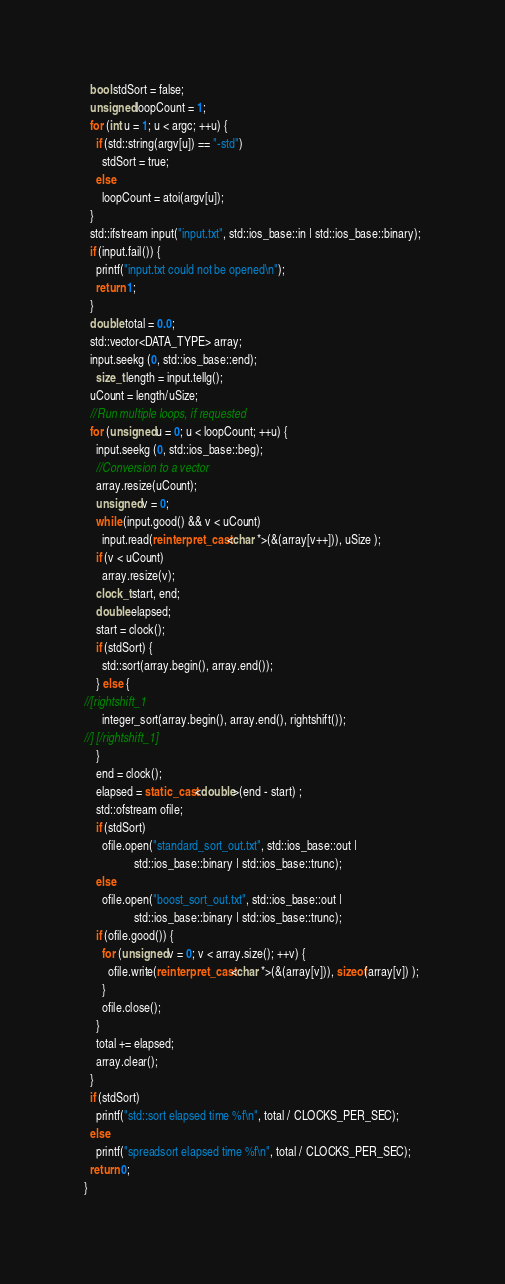<code> <loc_0><loc_0><loc_500><loc_500><_C++_>  bool stdSort = false;
  unsigned loopCount = 1;
  for (int u = 1; u < argc; ++u) {
    if (std::string(argv[u]) == "-std")
      stdSort = true;
    else
      loopCount = atoi(argv[u]);
  }
  std::ifstream input("input.txt", std::ios_base::in | std::ios_base::binary);
  if (input.fail()) {
    printf("input.txt could not be opened\n");
    return 1;
  }
  double total = 0.0;
  std::vector<DATA_TYPE> array;
  input.seekg (0, std::ios_base::end);
    size_t length = input.tellg();
  uCount = length/uSize;
  //Run multiple loops, if requested
  for (unsigned u = 0; u < loopCount; ++u) {
    input.seekg (0, std::ios_base::beg);
    //Conversion to a vector
    array.resize(uCount);
    unsigned v = 0;
    while (input.good() && v < uCount)
      input.read(reinterpret_cast<char *>(&(array[v++])), uSize );
    if (v < uCount)
      array.resize(v);
    clock_t start, end;
    double elapsed;
    start = clock();
    if (stdSort) {
      std::sort(array.begin(), array.end());
    } else {
//[rightshift_1
      integer_sort(array.begin(), array.end(), rightshift());
//] [/rightshift_1]
    }
    end = clock();
    elapsed = static_cast<double>(end - start) ;
    std::ofstream ofile;
    if (stdSort)
      ofile.open("standard_sort_out.txt", std::ios_base::out |
                 std::ios_base::binary | std::ios_base::trunc);
    else
      ofile.open("boost_sort_out.txt", std::ios_base::out |
                 std::ios_base::binary | std::ios_base::trunc);
    if (ofile.good()) {
      for (unsigned v = 0; v < array.size(); ++v) {
        ofile.write(reinterpret_cast<char *>(&(array[v])), sizeof(array[v]) );
      }
      ofile.close();
    }
    total += elapsed;
    array.clear();
  }
  if (stdSort)
    printf("std::sort elapsed time %f\n", total / CLOCKS_PER_SEC);
  else
    printf("spreadsort elapsed time %f\n", total / CLOCKS_PER_SEC);
  return 0;
}
</code> 